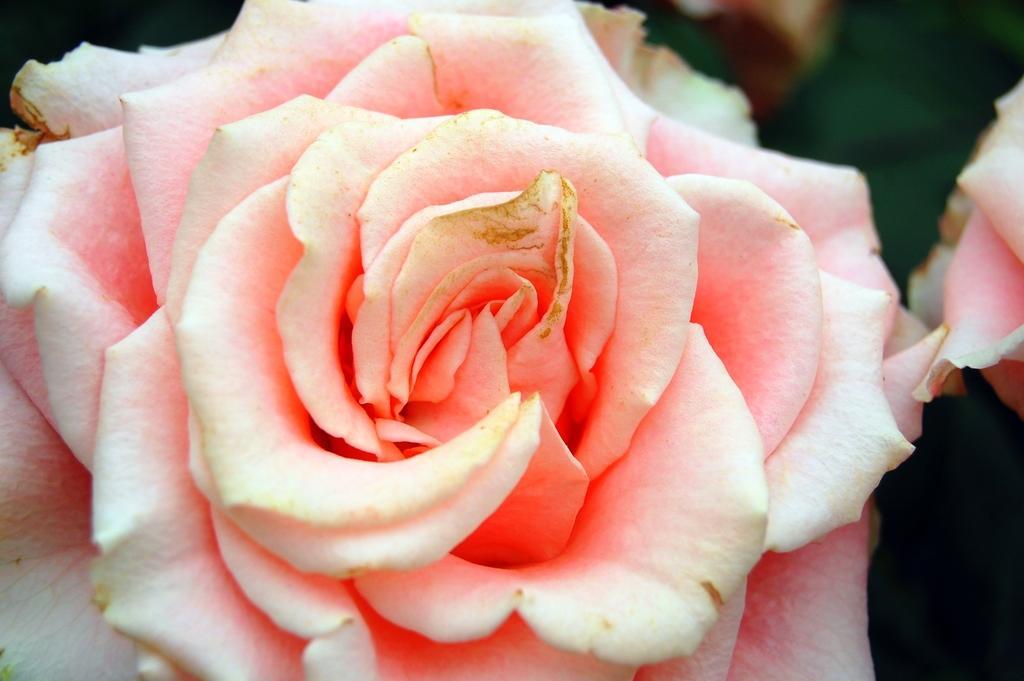Can you describe this image briefly? In this image we can see a flower. There is a blur background. 